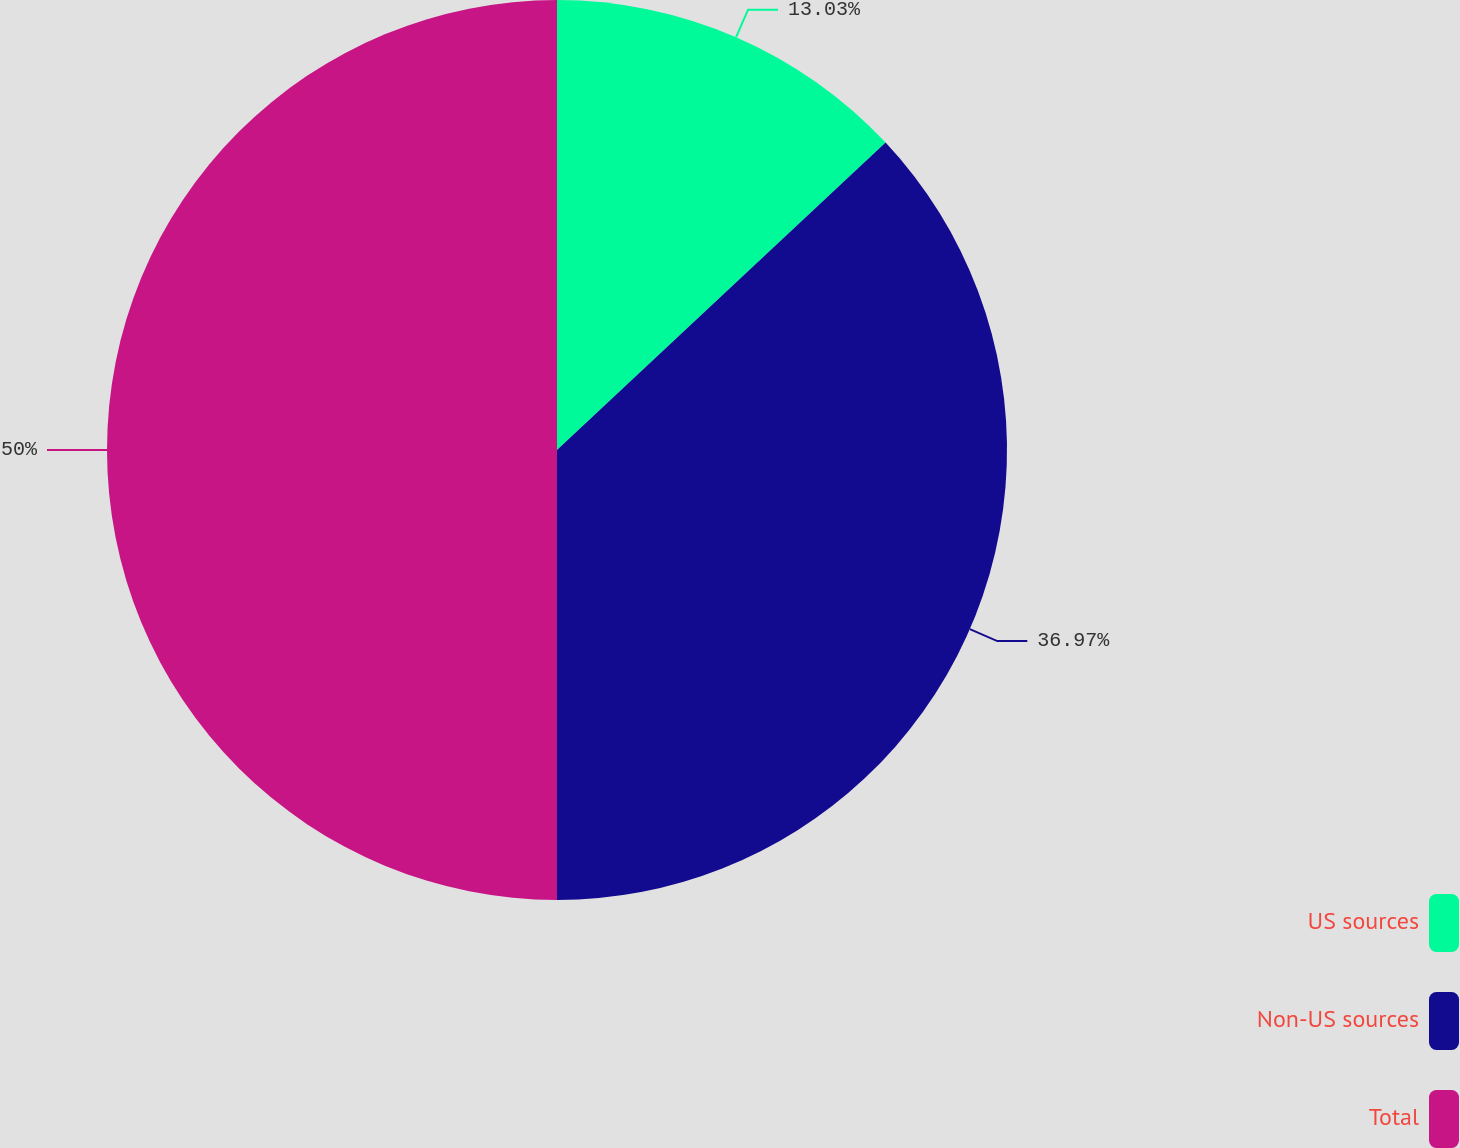<chart> <loc_0><loc_0><loc_500><loc_500><pie_chart><fcel>US sources<fcel>Non-US sources<fcel>Total<nl><fcel>13.03%<fcel>36.97%<fcel>50.0%<nl></chart> 